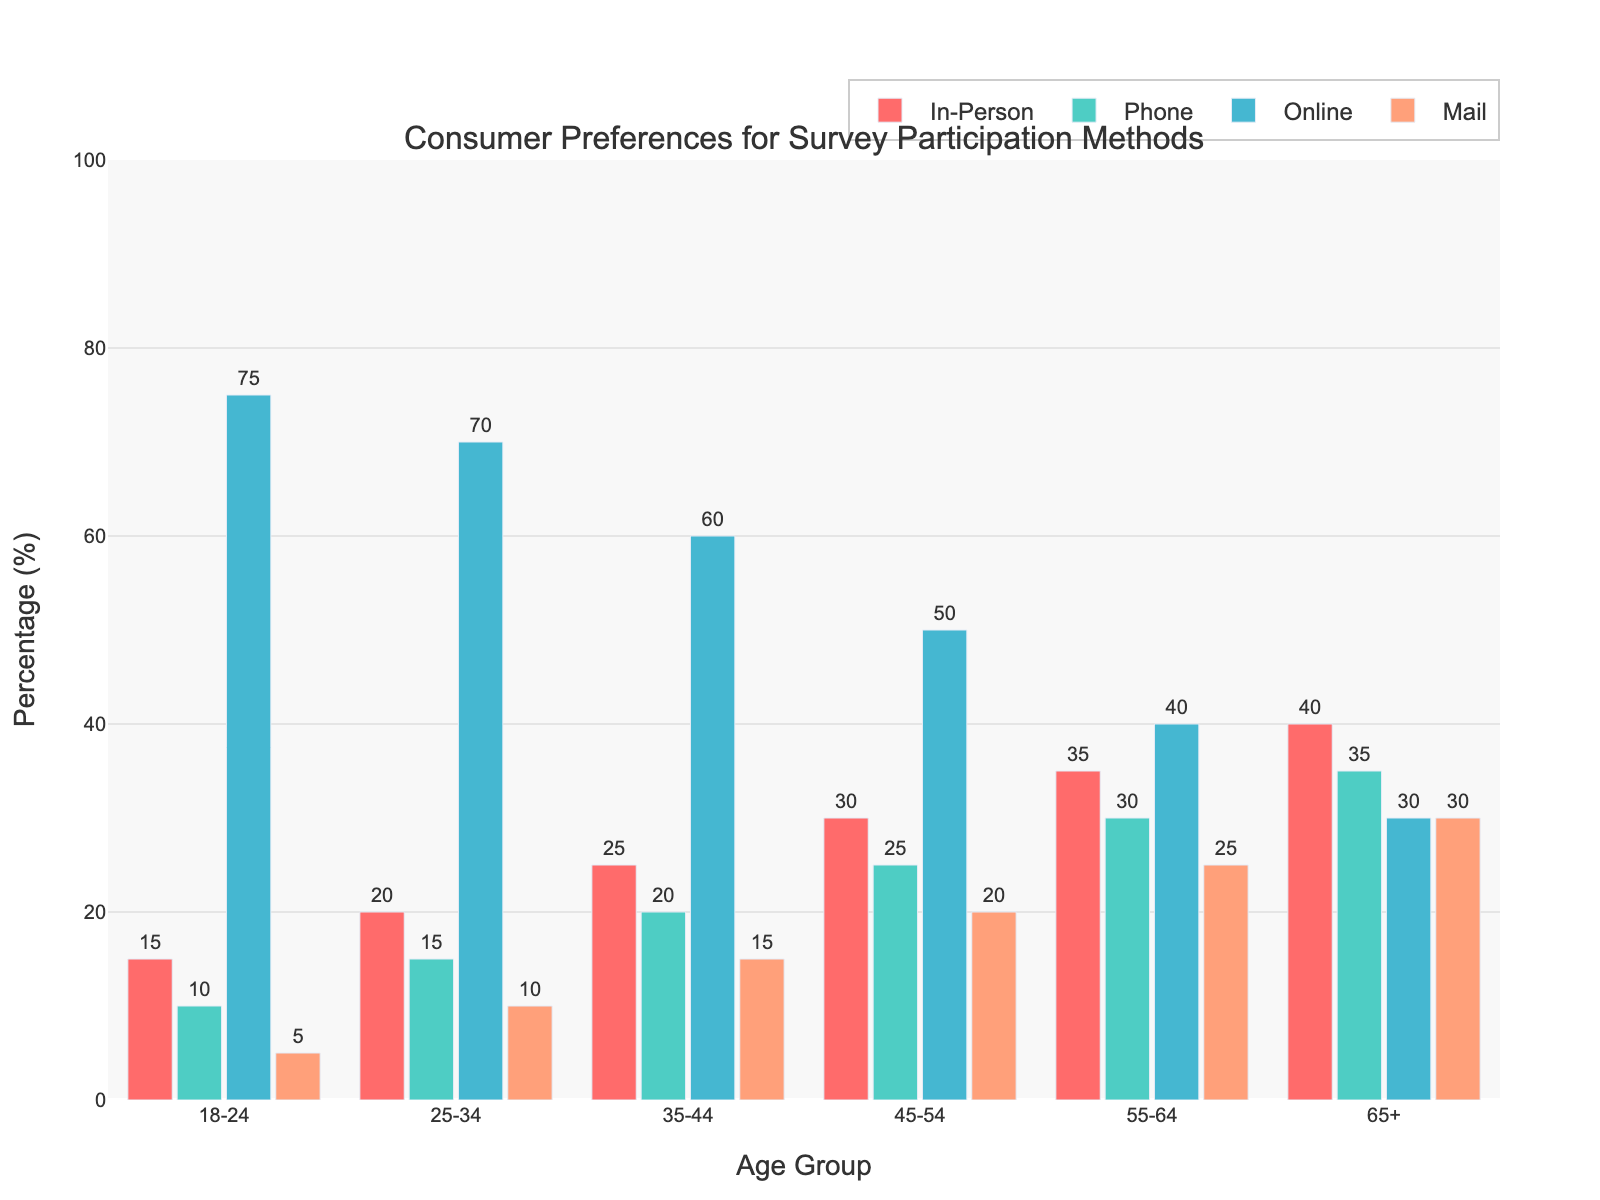What is the most preferred survey participation method for the 18-24 age group? First, identify each method's bar in the 18-24 age group. Then, find the bar with the highest length, which represents the most preferred method. The tallest bar for this age group is the online method.
Answer: Online Which age group prefers phone surveys the most? Identify the height of the bars representing phone survey preferences in each age group. The tallest bar, indicating the highest preference, is in the 65+ age group.
Answer: 65+ How does the preference for mail surveys change from the 18-24 age group to the 65+ age group? Note the heights of the bars for mail surveys for both age groups. The value increases from 5% in the 18-24 age group to 30% in the 65+ age group, showing a rising trend.
Answer: Increases Which survey method experiences the most consistent decrease in preference as age increases? Compare the slope of the bars for each method across the age groups. The online method bar consistently decreases from younger to older age groups.
Answer: Online What is the average preference percentage for in-person surveys across all age groups? Sum the percentages of in-person surveys for all age groups (15 + 20 + 25 + 30 + 35 + 40 = 165) and divide by the number of age groups (165 / 6).
Answer: 27.5 Does any age group show the same preference percentage for two different survey methods? Check for each age group if any two methods have bars of equal height. The 65+ age group shows equal preferences of 30% for both the online and mail methods.
Answer: Yes, 65+ Which age group has the largest difference in preference between in-person and online surveys? Calculate the differences in heights (percentages) between the in-person and online bars for each age group, and identify the largest one. The largest difference is in the 65+ age group (40 - 30 = 10%).
Answer: 65+ Compare the preference for mail surveys between the 45-54 and 55-64 age groups. Which group shows a higher preference, and by how much? Note the heights of the mail survey bars for the 45-54 and 55-64 age groups. The former is 20%, and the latter is 25%. The difference is 25% - 20% = 5%.
Answer: 55-64 by 5% For the 35-44 age group, what is the total preference percentage for all survey methods combined? Sum up the percentages for all methods in the 35-44 age group (25 + 20 + 60 + 15 = 120%).
Answer: 120 Between in-person and phone surveys, which method has greater preference variability among different age groups? Observe the range of heights for in-person and phone survey bars. In-person has a range from 15% to 40%, while phone ranges from 10% to 35%, which means in-person has greater variability.
Answer: In-person 